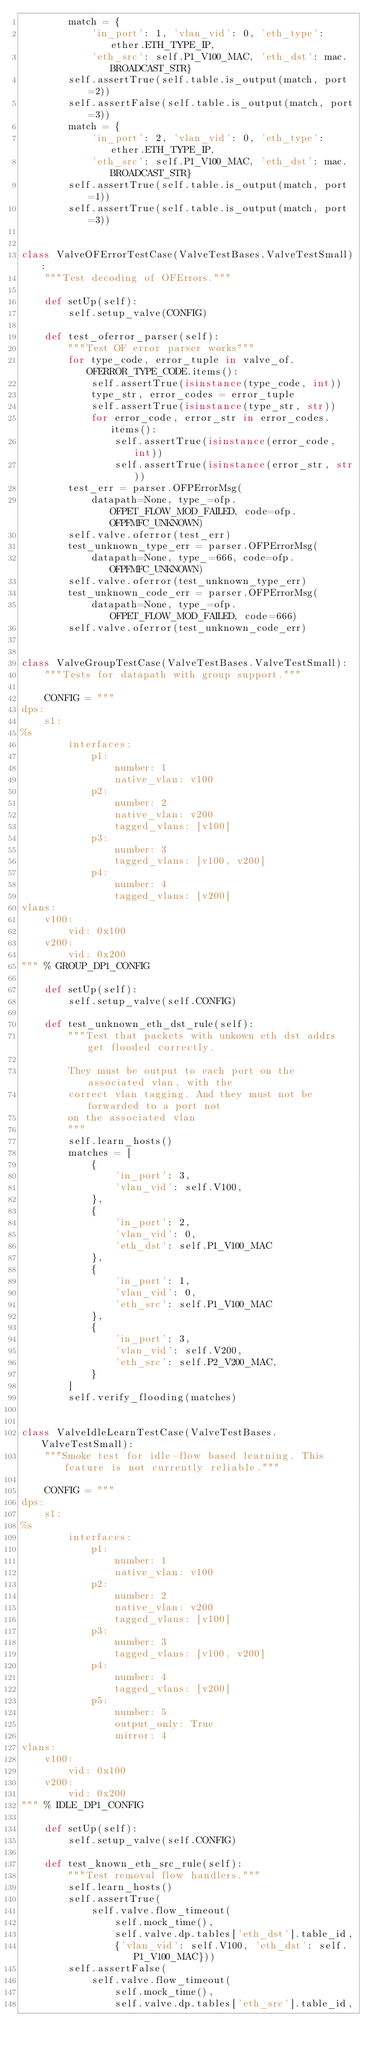Convert code to text. <code><loc_0><loc_0><loc_500><loc_500><_Python_>        match = {
            'in_port': 1, 'vlan_vid': 0, 'eth_type': ether.ETH_TYPE_IP,
            'eth_src': self.P1_V100_MAC, 'eth_dst': mac.BROADCAST_STR}
        self.assertTrue(self.table.is_output(match, port=2))
        self.assertFalse(self.table.is_output(match, port=3))
        match = {
            'in_port': 2, 'vlan_vid': 0, 'eth_type': ether.ETH_TYPE_IP,
            'eth_src': self.P1_V100_MAC, 'eth_dst': mac.BROADCAST_STR}
        self.assertTrue(self.table.is_output(match, port=1))
        self.assertTrue(self.table.is_output(match, port=3))


class ValveOFErrorTestCase(ValveTestBases.ValveTestSmall):
    """Test decoding of OFErrors."""

    def setUp(self):
        self.setup_valve(CONFIG)

    def test_oferror_parser(self):
        """Test OF error parser works"""
        for type_code, error_tuple in valve_of.OFERROR_TYPE_CODE.items():
            self.assertTrue(isinstance(type_code, int))
            type_str, error_codes = error_tuple
            self.assertTrue(isinstance(type_str, str))
            for error_code, error_str in error_codes.items():
                self.assertTrue(isinstance(error_code, int))
                self.assertTrue(isinstance(error_str, str))
        test_err = parser.OFPErrorMsg(
            datapath=None, type_=ofp.OFPET_FLOW_MOD_FAILED, code=ofp.OFPFMFC_UNKNOWN)
        self.valve.oferror(test_err)
        test_unknown_type_err = parser.OFPErrorMsg(
            datapath=None, type_=666, code=ofp.OFPFMFC_UNKNOWN)
        self.valve.oferror(test_unknown_type_err)
        test_unknown_code_err = parser.OFPErrorMsg(
            datapath=None, type_=ofp.OFPET_FLOW_MOD_FAILED, code=666)
        self.valve.oferror(test_unknown_code_err)


class ValveGroupTestCase(ValveTestBases.ValveTestSmall):
    """Tests for datapath with group support."""

    CONFIG = """
dps:
    s1:
%s
        interfaces:
            p1:
                number: 1
                native_vlan: v100
            p2:
                number: 2
                native_vlan: v200
                tagged_vlans: [v100]
            p3:
                number: 3
                tagged_vlans: [v100, v200]
            p4:
                number: 4
                tagged_vlans: [v200]
vlans:
    v100:
        vid: 0x100
    v200:
        vid: 0x200
""" % GROUP_DP1_CONFIG

    def setUp(self):
        self.setup_valve(self.CONFIG)

    def test_unknown_eth_dst_rule(self):
        """Test that packets with unkown eth dst addrs get flooded correctly.

        They must be output to each port on the associated vlan, with the
        correct vlan tagging. And they must not be forwarded to a port not
        on the associated vlan
        """
        self.learn_hosts()
        matches = [
            {
                'in_port': 3,
                'vlan_vid': self.V100,
            },
            {
                'in_port': 2,
                'vlan_vid': 0,
                'eth_dst': self.P1_V100_MAC
            },
            {
                'in_port': 1,
                'vlan_vid': 0,
                'eth_src': self.P1_V100_MAC
            },
            {
                'in_port': 3,
                'vlan_vid': self.V200,
                'eth_src': self.P2_V200_MAC,
            }
        ]
        self.verify_flooding(matches)


class ValveIdleLearnTestCase(ValveTestBases.ValveTestSmall):
    """Smoke test for idle-flow based learning. This feature is not currently reliable."""

    CONFIG = """
dps:
    s1:
%s
        interfaces:
            p1:
                number: 1
                native_vlan: v100
            p2:
                number: 2
                native_vlan: v200
                tagged_vlans: [v100]
            p3:
                number: 3
                tagged_vlans: [v100, v200]
            p4:
                number: 4
                tagged_vlans: [v200]
            p5:
                number: 5
                output_only: True
                mirror: 4
vlans:
    v100:
        vid: 0x100
    v200:
        vid: 0x200
""" % IDLE_DP1_CONFIG

    def setUp(self):
        self.setup_valve(self.CONFIG)

    def test_known_eth_src_rule(self):
        """Test removal flow handlers."""
        self.learn_hosts()
        self.assertTrue(
            self.valve.flow_timeout(
                self.mock_time(),
                self.valve.dp.tables['eth_dst'].table_id,
                {'vlan_vid': self.V100, 'eth_dst': self.P1_V100_MAC}))
        self.assertFalse(
            self.valve.flow_timeout(
                self.mock_time(),
                self.valve.dp.tables['eth_src'].table_id,</code> 